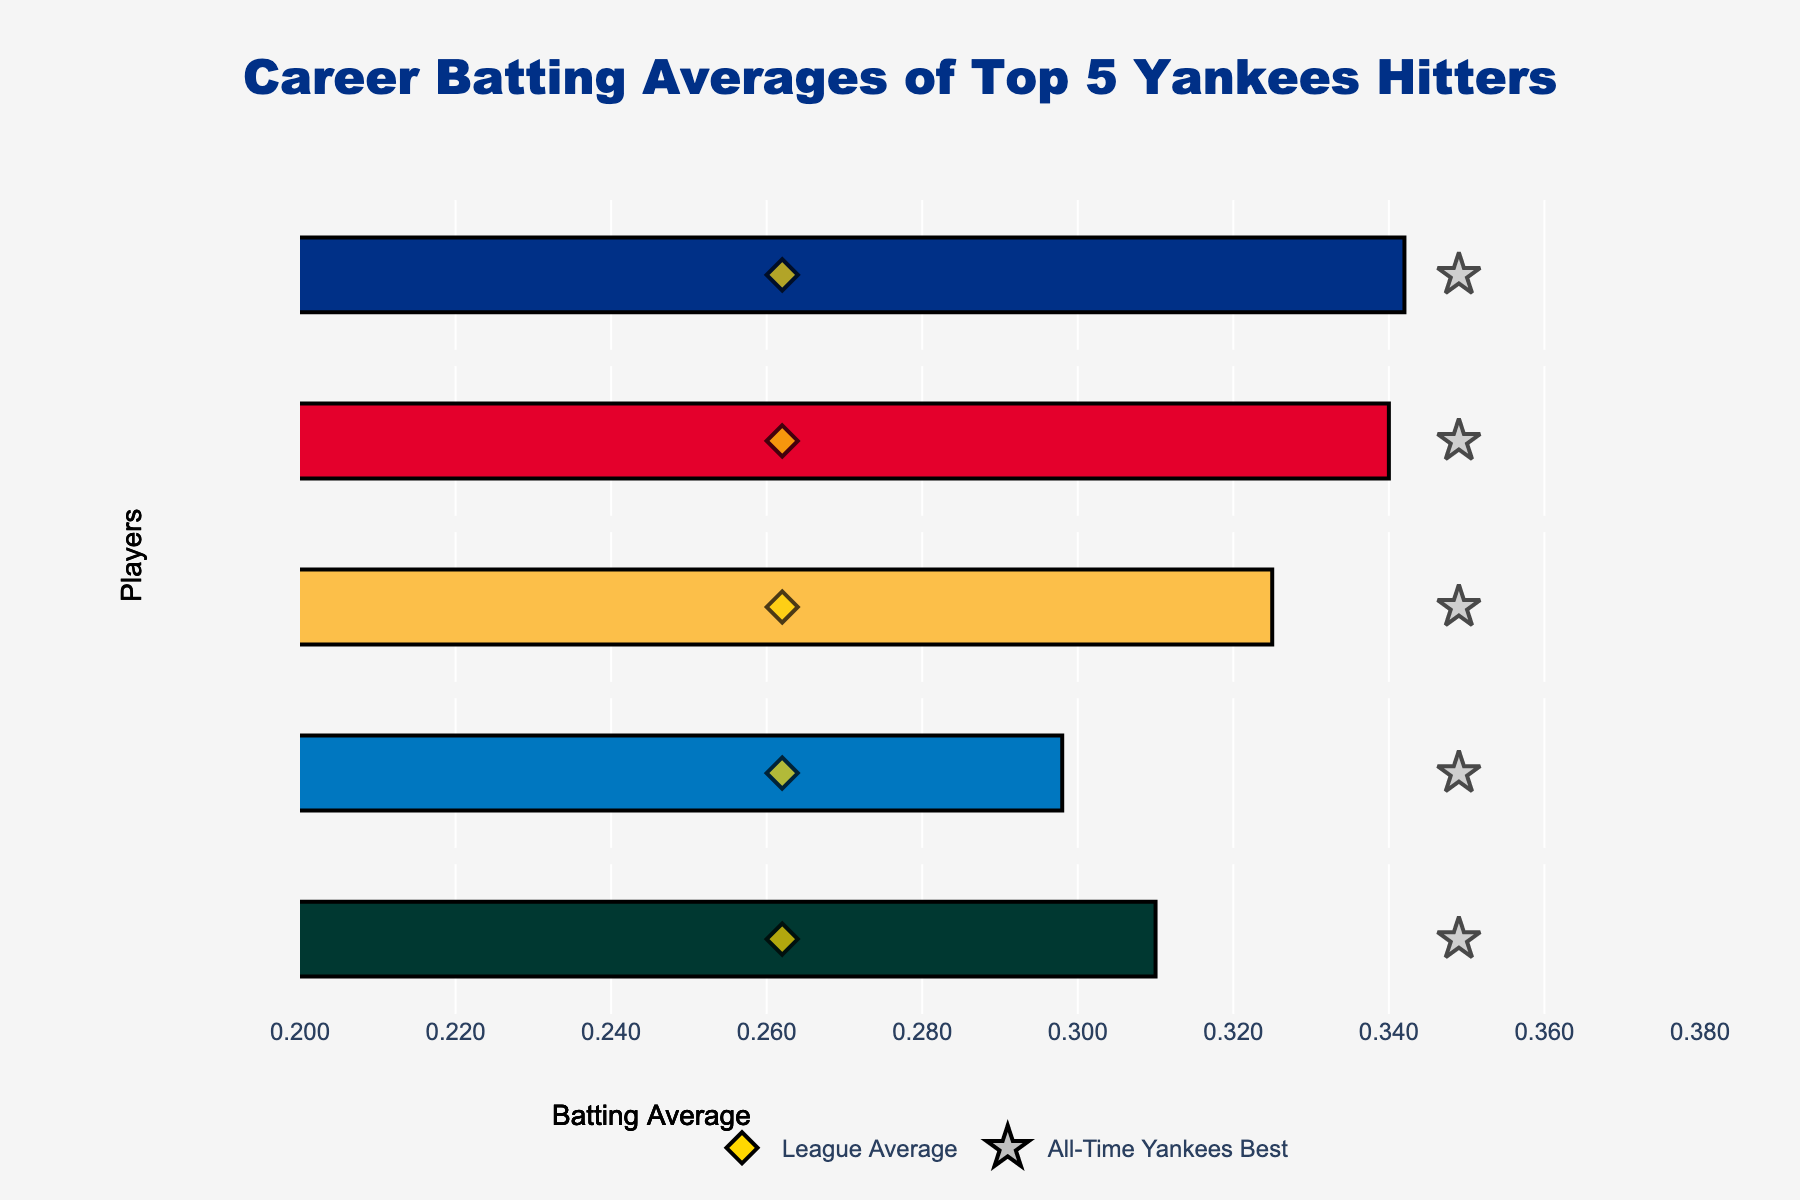Which player has the highest career batting average? Babe Ruth has the highest career batting average at 0.342. This is the maximum value among the career averages in the data.
Answer: Babe Ruth How does Lou Gehrig's batting average compare to the league average? Lou Gehrig's batting average is 0.340, which is higher than the league average of 0.262.
Answer: Higher Who are the players with a career batting average lower than the Yankees' all-time best? Mickey Mantle (0.298) and Derek Jeter (0.310) have career batting averages lower than the Yankees' all-time best of 0.349.
Answer: Mickey Mantle, Derek Jeter What is the range of career batting averages among the top 5 Yankees hitters? The highest batting average is 0.342 (Babe Ruth) and the lowest is 0.298 (Mickey Mantle). The range is 0.342 - 0.298 = 0.044.
Answer: 0.044 How many players have a career batting average above 0.320? Babe Ruth (0.342), Lou Gehrig (0.340), and Joe DiMaggio (0.325) each have a batting average above 0.320.
Answer: 3 Which player is closest to the Yankees' all-time best batting average? Lou Gehrig, with a career batting average of 0.340, is closest to the Yankees' all-time best of 0.349. The difference is 0.349 - 0.340 = 0.009.
Answer: Lou Gehrig What is the difference between Joe DiMaggio’s batting average and the league average? Joe DiMaggio’s batting average is 0.325, and the league average is 0.262. The difference is 0.325 - 0.262 = 0.063.
Answer: 0.063 Which player has the greatest difference between their career average and the league average? Babe Ruth has a career average of 0.342 and the league average is 0.262, a difference of 0.342 - 0.262 = 0.080. No other player has a larger difference.
Answer: Babe Ruth Does any player's batting average exceed the all-time Yankees best? No player's batting average exceeds the all-time Yankees best of 0.349.
Answer: No 